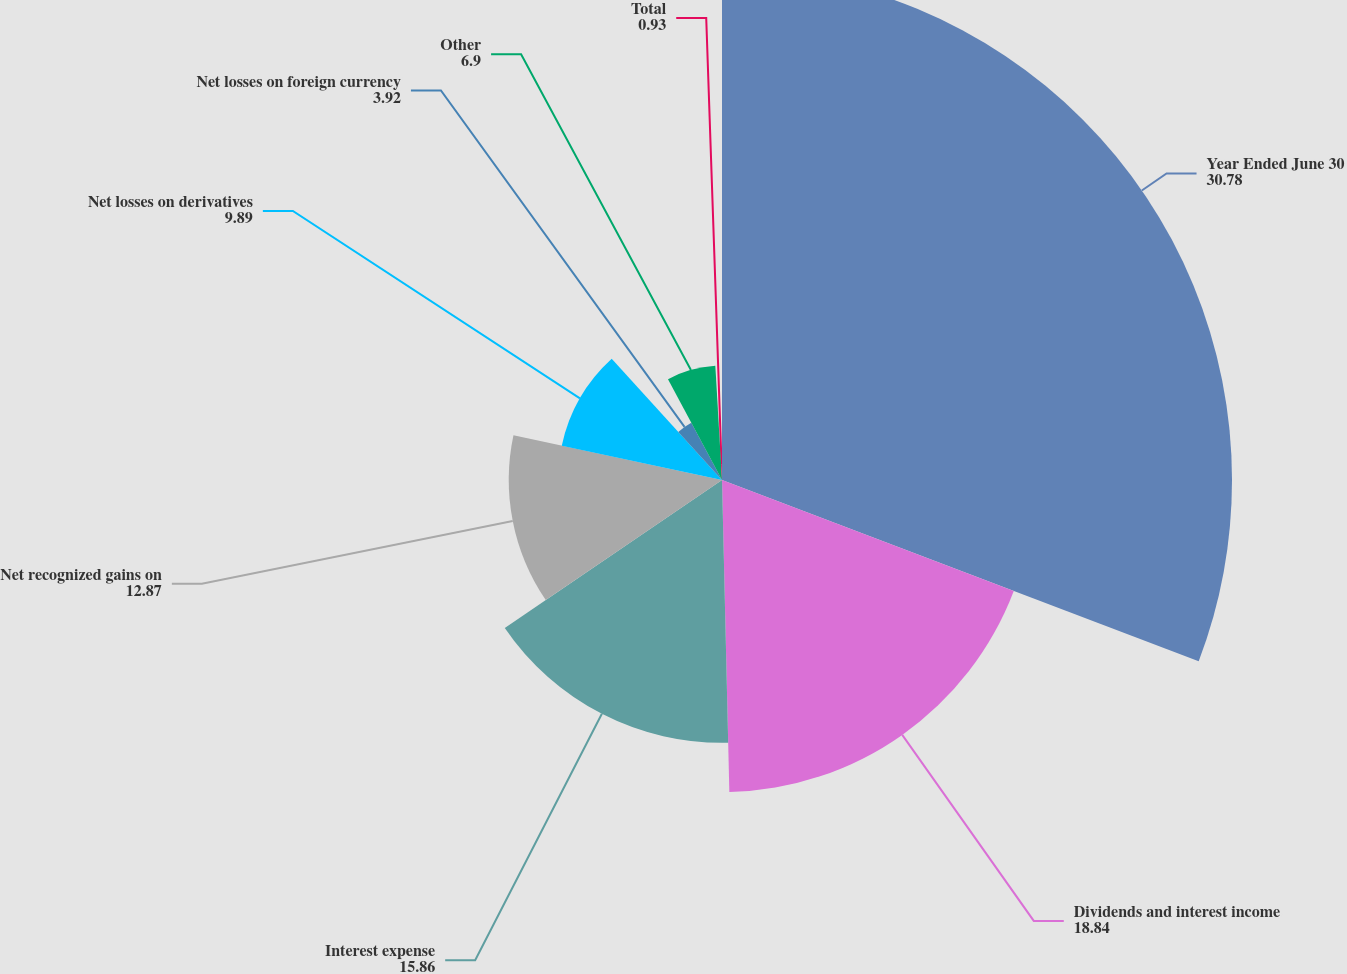<chart> <loc_0><loc_0><loc_500><loc_500><pie_chart><fcel>Year Ended June 30<fcel>Dividends and interest income<fcel>Interest expense<fcel>Net recognized gains on<fcel>Net losses on derivatives<fcel>Net losses on foreign currency<fcel>Other<fcel>Total<nl><fcel>30.78%<fcel>18.84%<fcel>15.86%<fcel>12.87%<fcel>9.89%<fcel>3.92%<fcel>6.9%<fcel>0.93%<nl></chart> 